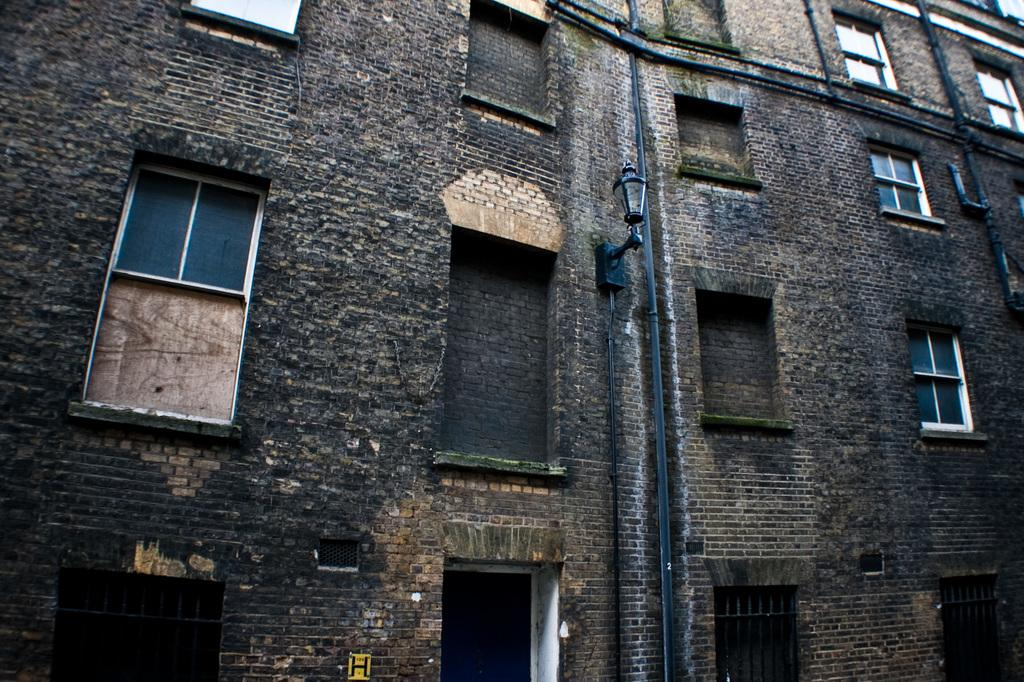What type of structure is present in the image? There is a building in the image. What feature can be seen on the building? The building has windows. Is there any illumination visible on the building? Yes, there is light visible on the building. What else can be found on the building wall? There are other objects on the building wall. What type of note is attached to the building in the image? There is no note attached to the building in the image. Can you see any dolls on the building in the image? There are no dolls present on the building in the image. 